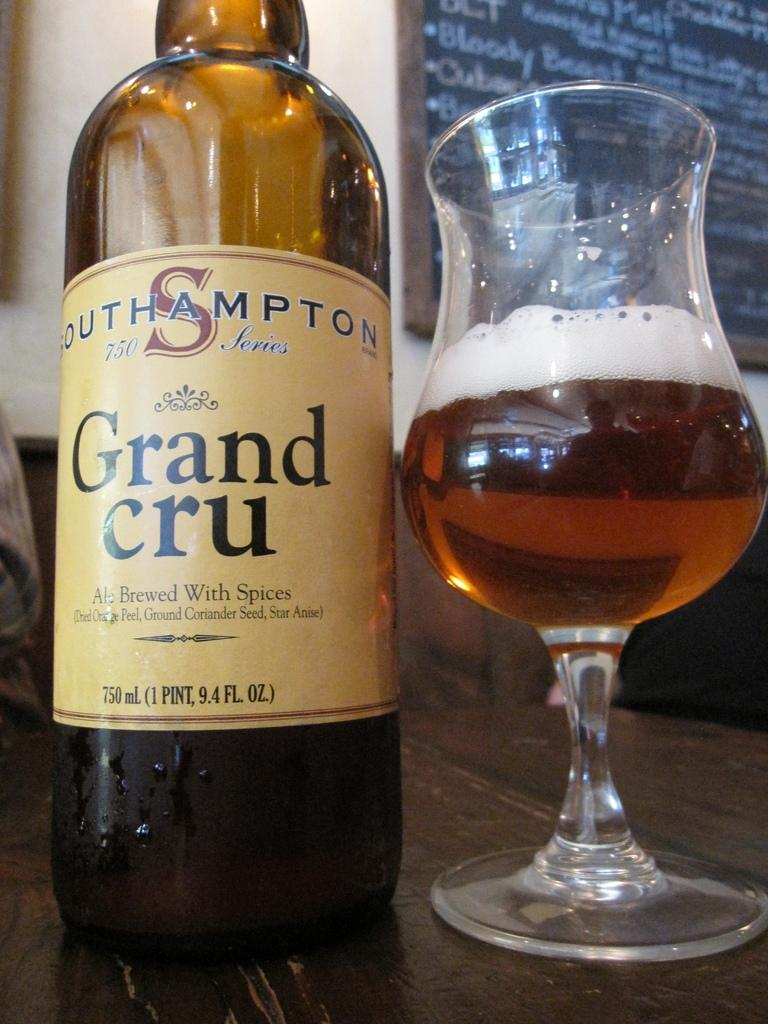<image>
Render a clear and concise summary of the photo. A bottle of SOUTHAMPTON Grand cru Ale Brewed With Spices. 